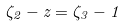Convert formula to latex. <formula><loc_0><loc_0><loc_500><loc_500>\zeta _ { 2 } - z = \zeta _ { 3 } - 1</formula> 